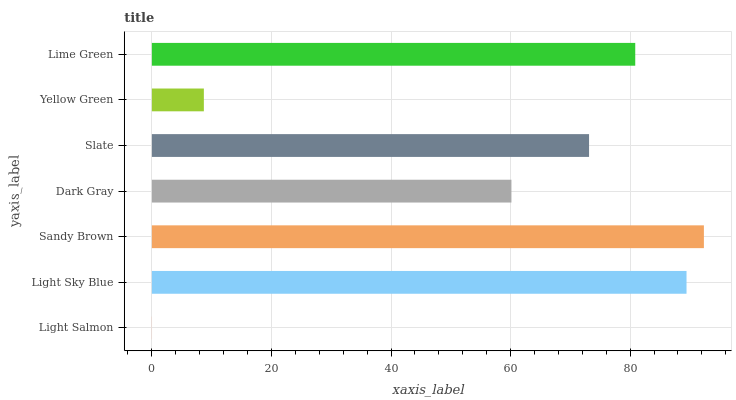Is Light Salmon the minimum?
Answer yes or no. Yes. Is Sandy Brown the maximum?
Answer yes or no. Yes. Is Light Sky Blue the minimum?
Answer yes or no. No. Is Light Sky Blue the maximum?
Answer yes or no. No. Is Light Sky Blue greater than Light Salmon?
Answer yes or no. Yes. Is Light Salmon less than Light Sky Blue?
Answer yes or no. Yes. Is Light Salmon greater than Light Sky Blue?
Answer yes or no. No. Is Light Sky Blue less than Light Salmon?
Answer yes or no. No. Is Slate the high median?
Answer yes or no. Yes. Is Slate the low median?
Answer yes or no. Yes. Is Light Sky Blue the high median?
Answer yes or no. No. Is Light Sky Blue the low median?
Answer yes or no. No. 